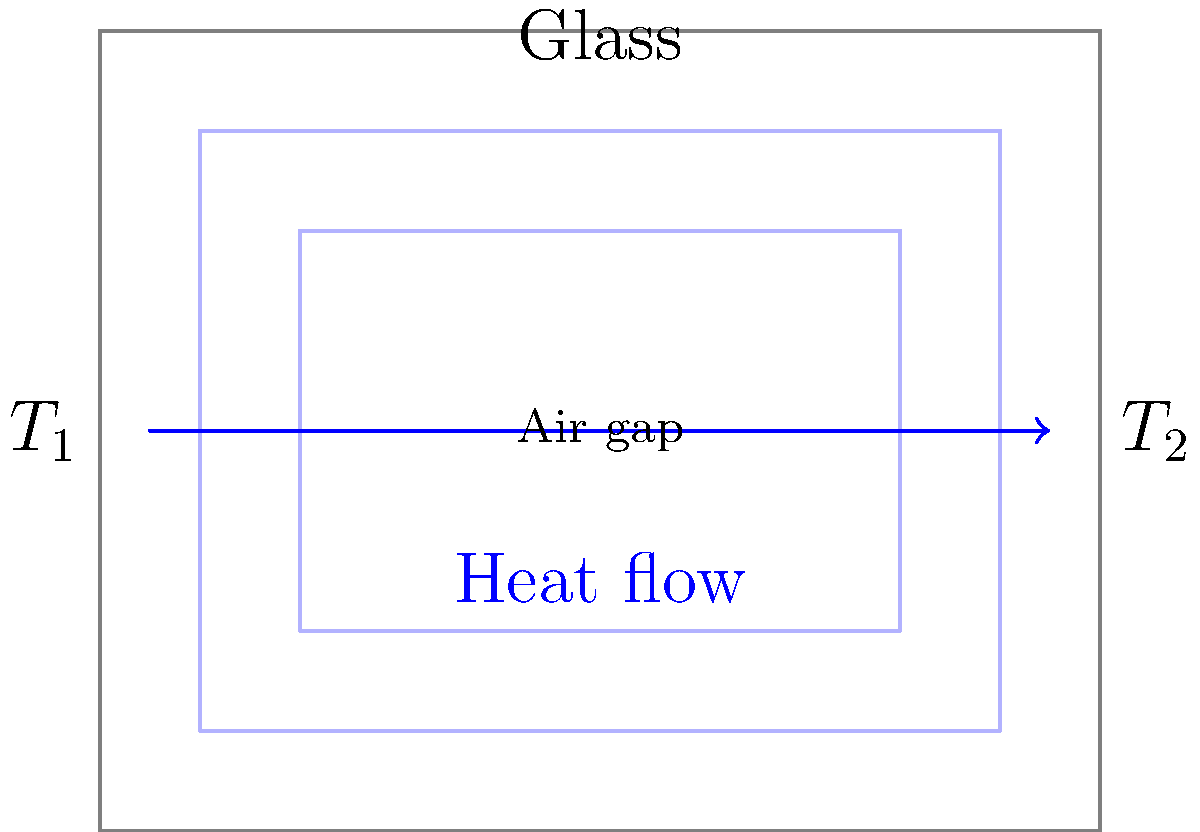A double-paned window consists of two glass panes separated by an air gap. The inner surface temperature is $T_1 = 20°C$, and the outer surface temperature is $T_2 = 0°C$. Each glass pane is 4 mm thick, and the air gap is 12 mm wide. The thermal conductivity of glass is 0.8 W/(m·K), and that of air is 0.024 W/(m·K). Calculate the heat transfer rate per square meter of window area. To solve this problem, we'll use the concept of thermal resistance in series. The heat transfer rate can be calculated using the following steps:

1. Calculate the thermal resistance of each layer:
   - Glass: $R_{glass} = \frac{L}{k} = \frac{0.004 \text{ m}}{0.8 \text{ W/(m·K)}} = 0.005 \text{ m²K/W}$
   - Air: $R_{air} = \frac{L}{k} = \frac{0.012 \text{ m}}{0.024 \text{ W/(m·K)}} = 0.5 \text{ m²K/W}$

2. Calculate the total thermal resistance:
   $R_{total} = R_{glass1} + R_{air} + R_{glass2} = 0.005 + 0.5 + 0.005 = 0.51 \text{ m²K/W}$

3. Calculate the temperature difference:
   $\Delta T = T_1 - T_2 = 20°C - 0°C = 20°C = 20 \text{ K}$

4. Use the heat transfer equation to calculate the heat transfer rate per square meter:
   $q = \frac{\Delta T}{R_{total}} = \frac{20 \text{ K}}{0.51 \text{ m²K/W}} = 39.22 \text{ W/m²}$

Therefore, the heat transfer rate per square meter of window area is approximately 39.22 W/m².
Answer: 39.22 W/m² 